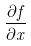Convert formula to latex. <formula><loc_0><loc_0><loc_500><loc_500>\frac { \partial f } { \partial x }</formula> 